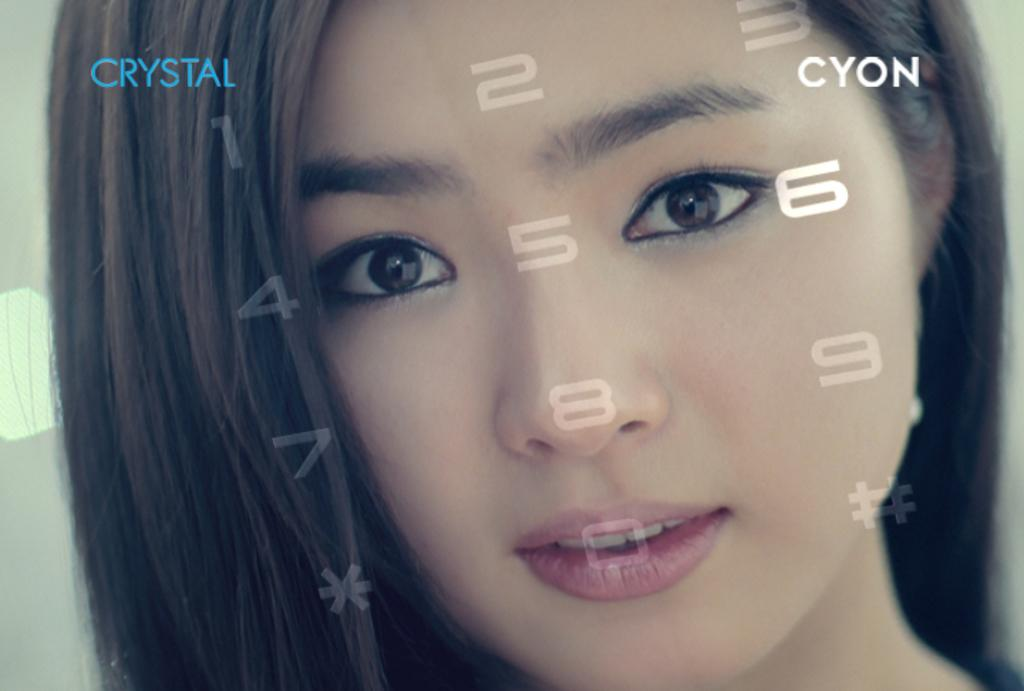What is the main subject of the picture? The main subject of the picture is a woman. Can you describe any additional features of the image? Yes, the image has watermarks. How many feet can be seen in the image? There is no mention of feet in the image, as it features a woman and watermarks. What type of rat is visible in the image? There is no rat present in the image; it only features a woman and watermarks. 